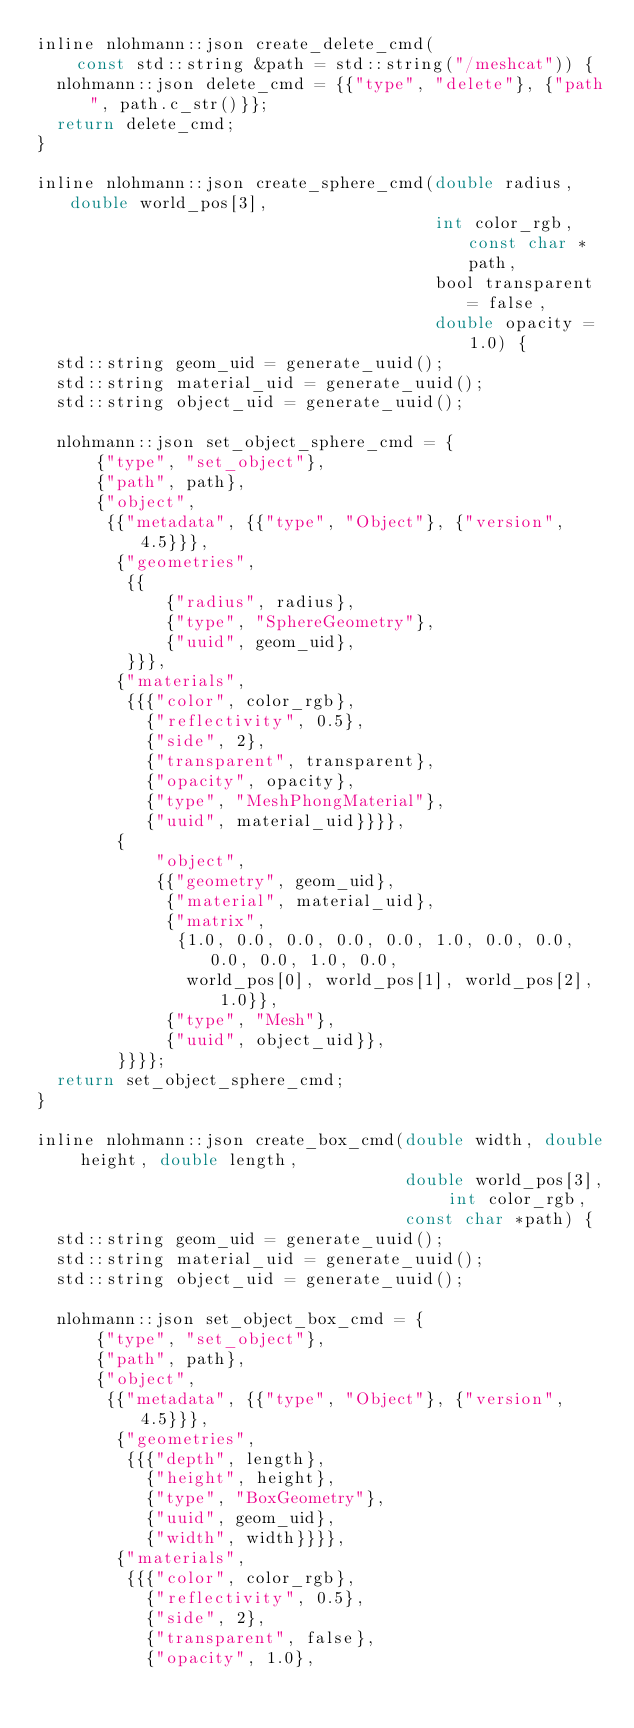Convert code to text. <code><loc_0><loc_0><loc_500><loc_500><_C_>inline nlohmann::json create_delete_cmd(
    const std::string &path = std::string("/meshcat")) {
  nlohmann::json delete_cmd = {{"type", "delete"}, {"path", path.c_str()}};
  return delete_cmd;
}

inline nlohmann::json create_sphere_cmd(double radius, double world_pos[3],
                                        int color_rgb, const char *path,
                                        bool transparent = false,
                                        double opacity = 1.0) {
  std::string geom_uid = generate_uuid();
  std::string material_uid = generate_uuid();
  std::string object_uid = generate_uuid();

  nlohmann::json set_object_sphere_cmd = {
      {"type", "set_object"},
      {"path", path},
      {"object",
       {{"metadata", {{"type", "Object"}, {"version", 4.5}}},
        {"geometries",
         {{
             {"radius", radius},
             {"type", "SphereGeometry"},
             {"uuid", geom_uid},
         }}},
        {"materials",
         {{{"color", color_rgb},
           {"reflectivity", 0.5},
           {"side", 2},
           {"transparent", transparent},
           {"opacity", opacity},
           {"type", "MeshPhongMaterial"},
           {"uuid", material_uid}}}},
        {
            "object",
            {{"geometry", geom_uid},
             {"material", material_uid},
             {"matrix",
              {1.0, 0.0, 0.0, 0.0, 0.0, 1.0, 0.0, 0.0, 0.0, 0.0, 1.0, 0.0,
               world_pos[0], world_pos[1], world_pos[2], 1.0}},
             {"type", "Mesh"},
             {"uuid", object_uid}},
        }}}};
  return set_object_sphere_cmd;
}

inline nlohmann::json create_box_cmd(double width, double height, double length,
                                     double world_pos[3], int color_rgb,
                                     const char *path) {
  std::string geom_uid = generate_uuid();
  std::string material_uid = generate_uuid();
  std::string object_uid = generate_uuid();

  nlohmann::json set_object_box_cmd = {
      {"type", "set_object"},
      {"path", path},
      {"object",
       {{"metadata", {{"type", "Object"}, {"version", 4.5}}},
        {"geometries",
         {{{"depth", length},
           {"height", height},
           {"type", "BoxGeometry"},
           {"uuid", geom_uid},
           {"width", width}}}},
        {"materials",
         {{{"color", color_rgb},
           {"reflectivity", 0.5},
           {"side", 2},
           {"transparent", false},
           {"opacity", 1.0},</code> 